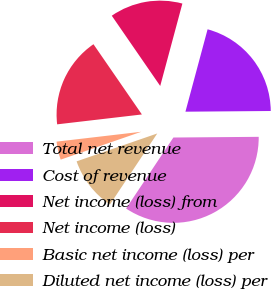Convert chart to OTSL. <chart><loc_0><loc_0><loc_500><loc_500><pie_chart><fcel>Total net revenue<fcel>Cost of revenue<fcel>Net income (loss) from<fcel>Net income (loss)<fcel>Basic net income (loss) per<fcel>Diluted net income (loss) per<nl><fcel>34.48%<fcel>20.69%<fcel>13.79%<fcel>17.24%<fcel>3.45%<fcel>10.35%<nl></chart> 